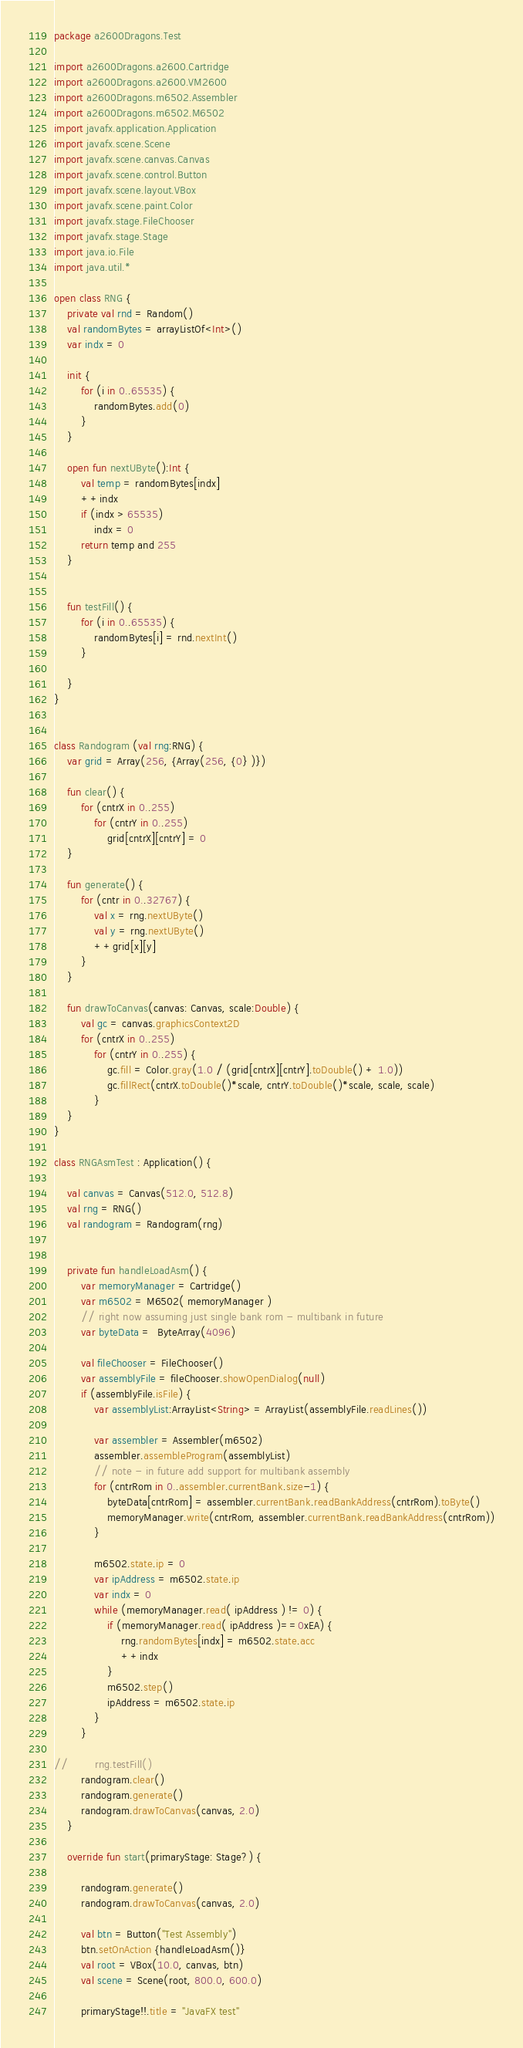Convert code to text. <code><loc_0><loc_0><loc_500><loc_500><_Kotlin_>package a2600Dragons.Test

import a2600Dragons.a2600.Cartridge
import a2600Dragons.a2600.VM2600
import a2600Dragons.m6502.Assembler
import a2600Dragons.m6502.M6502
import javafx.application.Application
import javafx.scene.Scene
import javafx.scene.canvas.Canvas
import javafx.scene.control.Button
import javafx.scene.layout.VBox
import javafx.scene.paint.Color
import javafx.stage.FileChooser
import javafx.stage.Stage
import java.io.File
import java.util.*

open class RNG {
    private val rnd = Random()
    val randomBytes = arrayListOf<Int>()
    var indx = 0

    init {
        for (i in 0..65535) {
            randomBytes.add(0)
        }
    }

    open fun nextUByte():Int {
        val temp = randomBytes[indx]
        ++indx
        if (indx > 65535)
            indx = 0
        return temp and 255
    }


    fun testFill() {
        for (i in 0..65535) {
            randomBytes[i] = rnd.nextInt()
        }

    }
}


class Randogram (val rng:RNG) {
    var grid = Array(256, {Array(256, {0} )})

    fun clear() {
        for (cntrX in 0..255)
            for (cntrY in 0..255)
                grid[cntrX][cntrY] = 0
    }

    fun generate() {
        for (cntr in 0..32767) {
            val x = rng.nextUByte()
            val y = rng.nextUByte()
            ++grid[x][y]
        }
    }

    fun drawToCanvas(canvas: Canvas, scale:Double) {
        val gc = canvas.graphicsContext2D
        for (cntrX in 0..255)
            for (cntrY in 0..255) {
                gc.fill = Color.gray(1.0 / (grid[cntrX][cntrY].toDouble() + 1.0))
                gc.fillRect(cntrX.toDouble()*scale, cntrY.toDouble()*scale, scale, scale)
            }
    }
}

class RNGAsmTest : Application() {

    val canvas = Canvas(512.0, 512.8)
    val rng = RNG()
    val randogram = Randogram(rng)


    private fun handleLoadAsm() {
        var memoryManager = Cartridge()
        var m6502 = M6502( memoryManager )
        // right now assuming just single bank rom - multibank in future
        var byteData =  ByteArray(4096)

        val fileChooser = FileChooser()
        var assemblyFile = fileChooser.showOpenDialog(null)
        if (assemblyFile.isFile) {
            var assemblyList:ArrayList<String> = ArrayList(assemblyFile.readLines())

            var assembler = Assembler(m6502)
            assembler.assembleProgram(assemblyList)
            // note - in future add support for multibank assembly
            for (cntrRom in 0..assembler.currentBank.size-1) {
                byteData[cntrRom] = assembler.currentBank.readBankAddress(cntrRom).toByte()
                memoryManager.write(cntrRom, assembler.currentBank.readBankAddress(cntrRom))
            }

            m6502.state.ip = 0
            var ipAddress = m6502.state.ip
            var indx = 0
            while (memoryManager.read( ipAddress ) != 0) {
                if (memoryManager.read( ipAddress )==0xEA) {
                    rng.randomBytes[indx] = m6502.state.acc
                    ++indx
                }
                m6502.step()
                ipAddress = m6502.state.ip
            }
        }

//        rng.testFill()
        randogram.clear()
        randogram.generate()
        randogram.drawToCanvas(canvas, 2.0)
    }

    override fun start(primaryStage: Stage?) {

        randogram.generate()
        randogram.drawToCanvas(canvas, 2.0)

        val btn = Button("Test Assembly")
        btn.setOnAction {handleLoadAsm()}
        val root = VBox(10.0, canvas, btn)
        val scene = Scene(root, 800.0, 600.0)

        primaryStage!!.title = "JavaFX test"</code> 